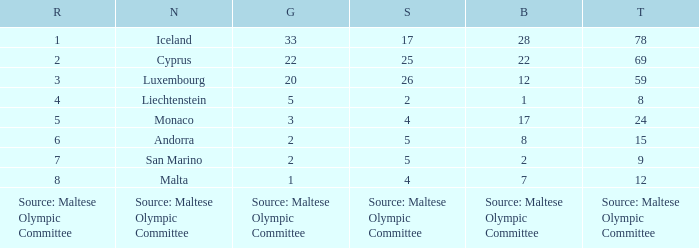What rank is the nation with 2 silver medals? 4.0. 